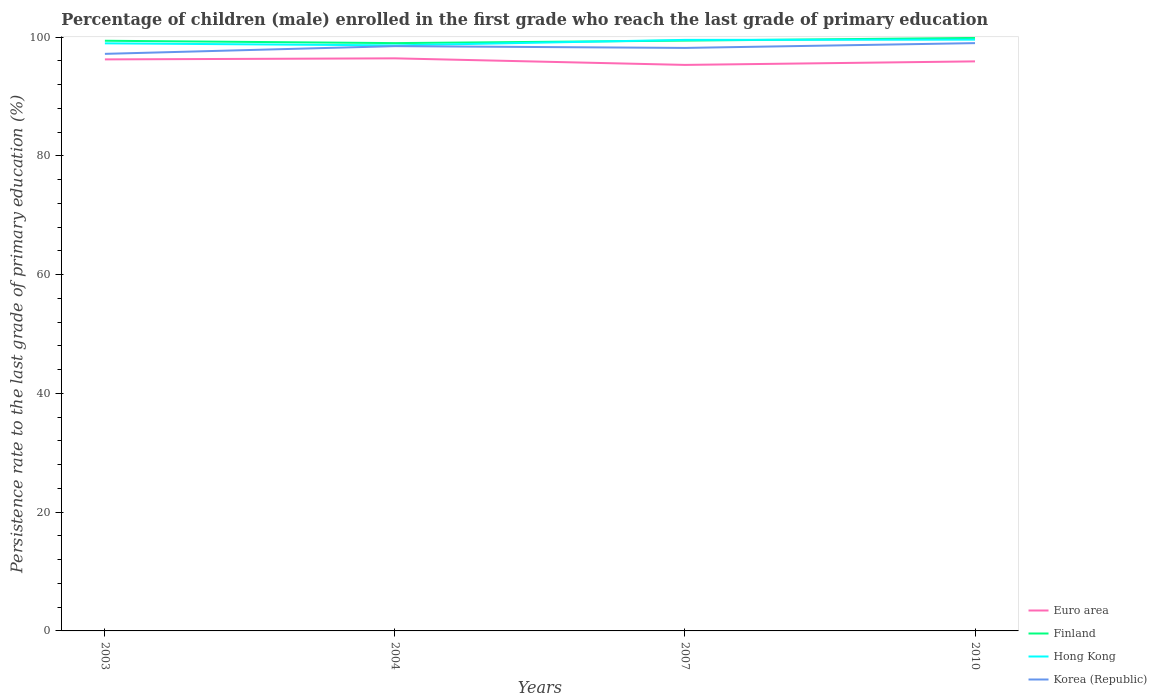How many different coloured lines are there?
Your answer should be very brief. 4. Does the line corresponding to Finland intersect with the line corresponding to Hong Kong?
Offer a very short reply. Yes. Is the number of lines equal to the number of legend labels?
Ensure brevity in your answer.  Yes. Across all years, what is the maximum persistence rate of children in Euro area?
Offer a terse response. 95.31. In which year was the persistence rate of children in Hong Kong maximum?
Your answer should be compact. 2004. What is the total persistence rate of children in Finland in the graph?
Keep it short and to the point. -0.42. What is the difference between the highest and the second highest persistence rate of children in Finland?
Provide a succinct answer. 0.87. What is the difference between the highest and the lowest persistence rate of children in Korea (Republic)?
Provide a short and direct response. 2. Is the persistence rate of children in Korea (Republic) strictly greater than the persistence rate of children in Finland over the years?
Your answer should be very brief. Yes. Are the values on the major ticks of Y-axis written in scientific E-notation?
Ensure brevity in your answer.  No. Does the graph contain any zero values?
Make the answer very short. No. How many legend labels are there?
Offer a very short reply. 4. What is the title of the graph?
Your answer should be very brief. Percentage of children (male) enrolled in the first grade who reach the last grade of primary education. What is the label or title of the X-axis?
Your answer should be compact. Years. What is the label or title of the Y-axis?
Provide a succinct answer. Persistence rate to the last grade of primary education (%). What is the Persistence rate to the last grade of primary education (%) of Euro area in 2003?
Provide a succinct answer. 96.24. What is the Persistence rate to the last grade of primary education (%) of Finland in 2003?
Make the answer very short. 99.38. What is the Persistence rate to the last grade of primary education (%) in Hong Kong in 2003?
Your response must be concise. 98.94. What is the Persistence rate to the last grade of primary education (%) of Korea (Republic) in 2003?
Give a very brief answer. 97.17. What is the Persistence rate to the last grade of primary education (%) in Euro area in 2004?
Your response must be concise. 96.41. What is the Persistence rate to the last grade of primary education (%) in Finland in 2004?
Offer a very short reply. 98.98. What is the Persistence rate to the last grade of primary education (%) of Hong Kong in 2004?
Provide a short and direct response. 98.6. What is the Persistence rate to the last grade of primary education (%) of Korea (Republic) in 2004?
Provide a succinct answer. 98.47. What is the Persistence rate to the last grade of primary education (%) of Euro area in 2007?
Your answer should be very brief. 95.31. What is the Persistence rate to the last grade of primary education (%) in Finland in 2007?
Ensure brevity in your answer.  99.4. What is the Persistence rate to the last grade of primary education (%) in Hong Kong in 2007?
Give a very brief answer. 99.52. What is the Persistence rate to the last grade of primary education (%) of Korea (Republic) in 2007?
Offer a terse response. 98.17. What is the Persistence rate to the last grade of primary education (%) of Euro area in 2010?
Offer a terse response. 95.9. What is the Persistence rate to the last grade of primary education (%) of Finland in 2010?
Give a very brief answer. 99.85. What is the Persistence rate to the last grade of primary education (%) of Hong Kong in 2010?
Your response must be concise. 99.56. What is the Persistence rate to the last grade of primary education (%) of Korea (Republic) in 2010?
Provide a short and direct response. 98.98. Across all years, what is the maximum Persistence rate to the last grade of primary education (%) of Euro area?
Provide a succinct answer. 96.41. Across all years, what is the maximum Persistence rate to the last grade of primary education (%) of Finland?
Ensure brevity in your answer.  99.85. Across all years, what is the maximum Persistence rate to the last grade of primary education (%) in Hong Kong?
Keep it short and to the point. 99.56. Across all years, what is the maximum Persistence rate to the last grade of primary education (%) in Korea (Republic)?
Your answer should be compact. 98.98. Across all years, what is the minimum Persistence rate to the last grade of primary education (%) in Euro area?
Keep it short and to the point. 95.31. Across all years, what is the minimum Persistence rate to the last grade of primary education (%) of Finland?
Keep it short and to the point. 98.98. Across all years, what is the minimum Persistence rate to the last grade of primary education (%) in Hong Kong?
Ensure brevity in your answer.  98.6. Across all years, what is the minimum Persistence rate to the last grade of primary education (%) of Korea (Republic)?
Give a very brief answer. 97.17. What is the total Persistence rate to the last grade of primary education (%) of Euro area in the graph?
Provide a short and direct response. 383.87. What is the total Persistence rate to the last grade of primary education (%) of Finland in the graph?
Give a very brief answer. 397.61. What is the total Persistence rate to the last grade of primary education (%) in Hong Kong in the graph?
Provide a succinct answer. 396.63. What is the total Persistence rate to the last grade of primary education (%) of Korea (Republic) in the graph?
Give a very brief answer. 392.79. What is the difference between the Persistence rate to the last grade of primary education (%) in Euro area in 2003 and that in 2004?
Ensure brevity in your answer.  -0.18. What is the difference between the Persistence rate to the last grade of primary education (%) in Finland in 2003 and that in 2004?
Provide a short and direct response. 0.4. What is the difference between the Persistence rate to the last grade of primary education (%) of Hong Kong in 2003 and that in 2004?
Provide a short and direct response. 0.34. What is the difference between the Persistence rate to the last grade of primary education (%) in Korea (Republic) in 2003 and that in 2004?
Offer a terse response. -1.3. What is the difference between the Persistence rate to the last grade of primary education (%) of Euro area in 2003 and that in 2007?
Your answer should be very brief. 0.93. What is the difference between the Persistence rate to the last grade of primary education (%) of Finland in 2003 and that in 2007?
Keep it short and to the point. -0.02. What is the difference between the Persistence rate to the last grade of primary education (%) of Hong Kong in 2003 and that in 2007?
Provide a succinct answer. -0.58. What is the difference between the Persistence rate to the last grade of primary education (%) of Korea (Republic) in 2003 and that in 2007?
Offer a very short reply. -1. What is the difference between the Persistence rate to the last grade of primary education (%) of Finland in 2003 and that in 2010?
Your answer should be very brief. -0.48. What is the difference between the Persistence rate to the last grade of primary education (%) in Hong Kong in 2003 and that in 2010?
Offer a very short reply. -0.62. What is the difference between the Persistence rate to the last grade of primary education (%) of Korea (Republic) in 2003 and that in 2010?
Your answer should be very brief. -1.81. What is the difference between the Persistence rate to the last grade of primary education (%) in Euro area in 2004 and that in 2007?
Your response must be concise. 1.1. What is the difference between the Persistence rate to the last grade of primary education (%) of Finland in 2004 and that in 2007?
Provide a succinct answer. -0.42. What is the difference between the Persistence rate to the last grade of primary education (%) of Hong Kong in 2004 and that in 2007?
Your response must be concise. -0.92. What is the difference between the Persistence rate to the last grade of primary education (%) in Korea (Republic) in 2004 and that in 2007?
Make the answer very short. 0.3. What is the difference between the Persistence rate to the last grade of primary education (%) in Euro area in 2004 and that in 2010?
Ensure brevity in your answer.  0.51. What is the difference between the Persistence rate to the last grade of primary education (%) of Finland in 2004 and that in 2010?
Offer a very short reply. -0.87. What is the difference between the Persistence rate to the last grade of primary education (%) in Hong Kong in 2004 and that in 2010?
Your answer should be compact. -0.97. What is the difference between the Persistence rate to the last grade of primary education (%) of Korea (Republic) in 2004 and that in 2010?
Ensure brevity in your answer.  -0.51. What is the difference between the Persistence rate to the last grade of primary education (%) of Euro area in 2007 and that in 2010?
Your response must be concise. -0.59. What is the difference between the Persistence rate to the last grade of primary education (%) of Finland in 2007 and that in 2010?
Keep it short and to the point. -0.45. What is the difference between the Persistence rate to the last grade of primary education (%) of Hong Kong in 2007 and that in 2010?
Your answer should be compact. -0.04. What is the difference between the Persistence rate to the last grade of primary education (%) in Korea (Republic) in 2007 and that in 2010?
Provide a succinct answer. -0.81. What is the difference between the Persistence rate to the last grade of primary education (%) in Euro area in 2003 and the Persistence rate to the last grade of primary education (%) in Finland in 2004?
Your answer should be very brief. -2.74. What is the difference between the Persistence rate to the last grade of primary education (%) in Euro area in 2003 and the Persistence rate to the last grade of primary education (%) in Hong Kong in 2004?
Make the answer very short. -2.36. What is the difference between the Persistence rate to the last grade of primary education (%) in Euro area in 2003 and the Persistence rate to the last grade of primary education (%) in Korea (Republic) in 2004?
Your answer should be compact. -2.23. What is the difference between the Persistence rate to the last grade of primary education (%) in Finland in 2003 and the Persistence rate to the last grade of primary education (%) in Hong Kong in 2004?
Offer a terse response. 0.78. What is the difference between the Persistence rate to the last grade of primary education (%) in Finland in 2003 and the Persistence rate to the last grade of primary education (%) in Korea (Republic) in 2004?
Make the answer very short. 0.91. What is the difference between the Persistence rate to the last grade of primary education (%) in Hong Kong in 2003 and the Persistence rate to the last grade of primary education (%) in Korea (Republic) in 2004?
Offer a terse response. 0.47. What is the difference between the Persistence rate to the last grade of primary education (%) in Euro area in 2003 and the Persistence rate to the last grade of primary education (%) in Finland in 2007?
Provide a succinct answer. -3.16. What is the difference between the Persistence rate to the last grade of primary education (%) of Euro area in 2003 and the Persistence rate to the last grade of primary education (%) of Hong Kong in 2007?
Keep it short and to the point. -3.28. What is the difference between the Persistence rate to the last grade of primary education (%) of Euro area in 2003 and the Persistence rate to the last grade of primary education (%) of Korea (Republic) in 2007?
Provide a short and direct response. -1.93. What is the difference between the Persistence rate to the last grade of primary education (%) of Finland in 2003 and the Persistence rate to the last grade of primary education (%) of Hong Kong in 2007?
Provide a succinct answer. -0.14. What is the difference between the Persistence rate to the last grade of primary education (%) of Finland in 2003 and the Persistence rate to the last grade of primary education (%) of Korea (Republic) in 2007?
Make the answer very short. 1.21. What is the difference between the Persistence rate to the last grade of primary education (%) in Hong Kong in 2003 and the Persistence rate to the last grade of primary education (%) in Korea (Republic) in 2007?
Offer a terse response. 0.77. What is the difference between the Persistence rate to the last grade of primary education (%) in Euro area in 2003 and the Persistence rate to the last grade of primary education (%) in Finland in 2010?
Provide a succinct answer. -3.62. What is the difference between the Persistence rate to the last grade of primary education (%) of Euro area in 2003 and the Persistence rate to the last grade of primary education (%) of Hong Kong in 2010?
Your answer should be compact. -3.33. What is the difference between the Persistence rate to the last grade of primary education (%) of Euro area in 2003 and the Persistence rate to the last grade of primary education (%) of Korea (Republic) in 2010?
Provide a short and direct response. -2.74. What is the difference between the Persistence rate to the last grade of primary education (%) in Finland in 2003 and the Persistence rate to the last grade of primary education (%) in Hong Kong in 2010?
Give a very brief answer. -0.19. What is the difference between the Persistence rate to the last grade of primary education (%) of Finland in 2003 and the Persistence rate to the last grade of primary education (%) of Korea (Republic) in 2010?
Give a very brief answer. 0.4. What is the difference between the Persistence rate to the last grade of primary education (%) of Hong Kong in 2003 and the Persistence rate to the last grade of primary education (%) of Korea (Republic) in 2010?
Offer a terse response. -0.03. What is the difference between the Persistence rate to the last grade of primary education (%) in Euro area in 2004 and the Persistence rate to the last grade of primary education (%) in Finland in 2007?
Offer a very short reply. -2.99. What is the difference between the Persistence rate to the last grade of primary education (%) of Euro area in 2004 and the Persistence rate to the last grade of primary education (%) of Hong Kong in 2007?
Offer a very short reply. -3.11. What is the difference between the Persistence rate to the last grade of primary education (%) of Euro area in 2004 and the Persistence rate to the last grade of primary education (%) of Korea (Republic) in 2007?
Give a very brief answer. -1.76. What is the difference between the Persistence rate to the last grade of primary education (%) of Finland in 2004 and the Persistence rate to the last grade of primary education (%) of Hong Kong in 2007?
Ensure brevity in your answer.  -0.54. What is the difference between the Persistence rate to the last grade of primary education (%) in Finland in 2004 and the Persistence rate to the last grade of primary education (%) in Korea (Republic) in 2007?
Make the answer very short. 0.81. What is the difference between the Persistence rate to the last grade of primary education (%) of Hong Kong in 2004 and the Persistence rate to the last grade of primary education (%) of Korea (Republic) in 2007?
Make the answer very short. 0.43. What is the difference between the Persistence rate to the last grade of primary education (%) of Euro area in 2004 and the Persistence rate to the last grade of primary education (%) of Finland in 2010?
Make the answer very short. -3.44. What is the difference between the Persistence rate to the last grade of primary education (%) in Euro area in 2004 and the Persistence rate to the last grade of primary education (%) in Hong Kong in 2010?
Offer a very short reply. -3.15. What is the difference between the Persistence rate to the last grade of primary education (%) in Euro area in 2004 and the Persistence rate to the last grade of primary education (%) in Korea (Republic) in 2010?
Your answer should be very brief. -2.56. What is the difference between the Persistence rate to the last grade of primary education (%) of Finland in 2004 and the Persistence rate to the last grade of primary education (%) of Hong Kong in 2010?
Your answer should be compact. -0.58. What is the difference between the Persistence rate to the last grade of primary education (%) in Finland in 2004 and the Persistence rate to the last grade of primary education (%) in Korea (Republic) in 2010?
Your answer should be compact. 0. What is the difference between the Persistence rate to the last grade of primary education (%) of Hong Kong in 2004 and the Persistence rate to the last grade of primary education (%) of Korea (Republic) in 2010?
Your answer should be compact. -0.38. What is the difference between the Persistence rate to the last grade of primary education (%) in Euro area in 2007 and the Persistence rate to the last grade of primary education (%) in Finland in 2010?
Offer a very short reply. -4.54. What is the difference between the Persistence rate to the last grade of primary education (%) of Euro area in 2007 and the Persistence rate to the last grade of primary education (%) of Hong Kong in 2010?
Your answer should be compact. -4.25. What is the difference between the Persistence rate to the last grade of primary education (%) in Euro area in 2007 and the Persistence rate to the last grade of primary education (%) in Korea (Republic) in 2010?
Your response must be concise. -3.67. What is the difference between the Persistence rate to the last grade of primary education (%) in Finland in 2007 and the Persistence rate to the last grade of primary education (%) in Hong Kong in 2010?
Give a very brief answer. -0.16. What is the difference between the Persistence rate to the last grade of primary education (%) in Finland in 2007 and the Persistence rate to the last grade of primary education (%) in Korea (Republic) in 2010?
Your answer should be very brief. 0.42. What is the difference between the Persistence rate to the last grade of primary education (%) of Hong Kong in 2007 and the Persistence rate to the last grade of primary education (%) of Korea (Republic) in 2010?
Offer a very short reply. 0.55. What is the average Persistence rate to the last grade of primary education (%) in Euro area per year?
Make the answer very short. 95.97. What is the average Persistence rate to the last grade of primary education (%) of Finland per year?
Your response must be concise. 99.4. What is the average Persistence rate to the last grade of primary education (%) in Hong Kong per year?
Ensure brevity in your answer.  99.16. What is the average Persistence rate to the last grade of primary education (%) of Korea (Republic) per year?
Make the answer very short. 98.2. In the year 2003, what is the difference between the Persistence rate to the last grade of primary education (%) of Euro area and Persistence rate to the last grade of primary education (%) of Finland?
Provide a short and direct response. -3.14. In the year 2003, what is the difference between the Persistence rate to the last grade of primary education (%) in Euro area and Persistence rate to the last grade of primary education (%) in Hong Kong?
Offer a very short reply. -2.71. In the year 2003, what is the difference between the Persistence rate to the last grade of primary education (%) of Euro area and Persistence rate to the last grade of primary education (%) of Korea (Republic)?
Give a very brief answer. -0.93. In the year 2003, what is the difference between the Persistence rate to the last grade of primary education (%) in Finland and Persistence rate to the last grade of primary education (%) in Hong Kong?
Your answer should be very brief. 0.43. In the year 2003, what is the difference between the Persistence rate to the last grade of primary education (%) of Finland and Persistence rate to the last grade of primary education (%) of Korea (Republic)?
Provide a succinct answer. 2.21. In the year 2003, what is the difference between the Persistence rate to the last grade of primary education (%) in Hong Kong and Persistence rate to the last grade of primary education (%) in Korea (Republic)?
Your answer should be very brief. 1.77. In the year 2004, what is the difference between the Persistence rate to the last grade of primary education (%) in Euro area and Persistence rate to the last grade of primary education (%) in Finland?
Offer a very short reply. -2.56. In the year 2004, what is the difference between the Persistence rate to the last grade of primary education (%) in Euro area and Persistence rate to the last grade of primary education (%) in Hong Kong?
Offer a very short reply. -2.18. In the year 2004, what is the difference between the Persistence rate to the last grade of primary education (%) in Euro area and Persistence rate to the last grade of primary education (%) in Korea (Republic)?
Provide a succinct answer. -2.06. In the year 2004, what is the difference between the Persistence rate to the last grade of primary education (%) of Finland and Persistence rate to the last grade of primary education (%) of Hong Kong?
Your response must be concise. 0.38. In the year 2004, what is the difference between the Persistence rate to the last grade of primary education (%) of Finland and Persistence rate to the last grade of primary education (%) of Korea (Republic)?
Offer a terse response. 0.51. In the year 2004, what is the difference between the Persistence rate to the last grade of primary education (%) in Hong Kong and Persistence rate to the last grade of primary education (%) in Korea (Republic)?
Ensure brevity in your answer.  0.13. In the year 2007, what is the difference between the Persistence rate to the last grade of primary education (%) in Euro area and Persistence rate to the last grade of primary education (%) in Finland?
Offer a terse response. -4.09. In the year 2007, what is the difference between the Persistence rate to the last grade of primary education (%) in Euro area and Persistence rate to the last grade of primary education (%) in Hong Kong?
Offer a terse response. -4.21. In the year 2007, what is the difference between the Persistence rate to the last grade of primary education (%) in Euro area and Persistence rate to the last grade of primary education (%) in Korea (Republic)?
Offer a very short reply. -2.86. In the year 2007, what is the difference between the Persistence rate to the last grade of primary education (%) in Finland and Persistence rate to the last grade of primary education (%) in Hong Kong?
Your response must be concise. -0.12. In the year 2007, what is the difference between the Persistence rate to the last grade of primary education (%) in Finland and Persistence rate to the last grade of primary education (%) in Korea (Republic)?
Keep it short and to the point. 1.23. In the year 2007, what is the difference between the Persistence rate to the last grade of primary education (%) of Hong Kong and Persistence rate to the last grade of primary education (%) of Korea (Republic)?
Give a very brief answer. 1.35. In the year 2010, what is the difference between the Persistence rate to the last grade of primary education (%) of Euro area and Persistence rate to the last grade of primary education (%) of Finland?
Provide a succinct answer. -3.95. In the year 2010, what is the difference between the Persistence rate to the last grade of primary education (%) in Euro area and Persistence rate to the last grade of primary education (%) in Hong Kong?
Your response must be concise. -3.66. In the year 2010, what is the difference between the Persistence rate to the last grade of primary education (%) of Euro area and Persistence rate to the last grade of primary education (%) of Korea (Republic)?
Your answer should be very brief. -3.07. In the year 2010, what is the difference between the Persistence rate to the last grade of primary education (%) of Finland and Persistence rate to the last grade of primary education (%) of Hong Kong?
Your response must be concise. 0.29. In the year 2010, what is the difference between the Persistence rate to the last grade of primary education (%) of Finland and Persistence rate to the last grade of primary education (%) of Korea (Republic)?
Offer a very short reply. 0.88. In the year 2010, what is the difference between the Persistence rate to the last grade of primary education (%) in Hong Kong and Persistence rate to the last grade of primary education (%) in Korea (Republic)?
Your answer should be compact. 0.59. What is the ratio of the Persistence rate to the last grade of primary education (%) of Hong Kong in 2003 to that in 2004?
Provide a succinct answer. 1. What is the ratio of the Persistence rate to the last grade of primary education (%) in Euro area in 2003 to that in 2007?
Offer a very short reply. 1.01. What is the ratio of the Persistence rate to the last grade of primary education (%) in Finland in 2003 to that in 2007?
Your response must be concise. 1. What is the ratio of the Persistence rate to the last grade of primary education (%) of Hong Kong in 2003 to that in 2007?
Make the answer very short. 0.99. What is the ratio of the Persistence rate to the last grade of primary education (%) in Euro area in 2003 to that in 2010?
Your answer should be very brief. 1. What is the ratio of the Persistence rate to the last grade of primary education (%) in Hong Kong in 2003 to that in 2010?
Your answer should be compact. 0.99. What is the ratio of the Persistence rate to the last grade of primary education (%) in Korea (Republic) in 2003 to that in 2010?
Give a very brief answer. 0.98. What is the ratio of the Persistence rate to the last grade of primary education (%) of Euro area in 2004 to that in 2007?
Offer a very short reply. 1.01. What is the ratio of the Persistence rate to the last grade of primary education (%) in Korea (Republic) in 2004 to that in 2007?
Provide a succinct answer. 1. What is the ratio of the Persistence rate to the last grade of primary education (%) in Euro area in 2004 to that in 2010?
Give a very brief answer. 1.01. What is the ratio of the Persistence rate to the last grade of primary education (%) of Hong Kong in 2004 to that in 2010?
Your answer should be compact. 0.99. What is the ratio of the Persistence rate to the last grade of primary education (%) of Hong Kong in 2007 to that in 2010?
Make the answer very short. 1. What is the ratio of the Persistence rate to the last grade of primary education (%) in Korea (Republic) in 2007 to that in 2010?
Ensure brevity in your answer.  0.99. What is the difference between the highest and the second highest Persistence rate to the last grade of primary education (%) in Euro area?
Your answer should be compact. 0.18. What is the difference between the highest and the second highest Persistence rate to the last grade of primary education (%) of Finland?
Give a very brief answer. 0.45. What is the difference between the highest and the second highest Persistence rate to the last grade of primary education (%) of Hong Kong?
Ensure brevity in your answer.  0.04. What is the difference between the highest and the second highest Persistence rate to the last grade of primary education (%) of Korea (Republic)?
Offer a very short reply. 0.51. What is the difference between the highest and the lowest Persistence rate to the last grade of primary education (%) of Euro area?
Make the answer very short. 1.1. What is the difference between the highest and the lowest Persistence rate to the last grade of primary education (%) in Finland?
Offer a terse response. 0.87. What is the difference between the highest and the lowest Persistence rate to the last grade of primary education (%) of Hong Kong?
Ensure brevity in your answer.  0.97. What is the difference between the highest and the lowest Persistence rate to the last grade of primary education (%) of Korea (Republic)?
Offer a very short reply. 1.81. 